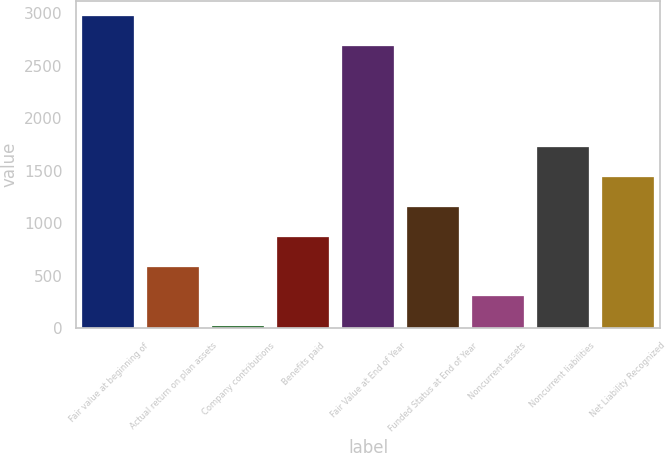Convert chart. <chart><loc_0><loc_0><loc_500><loc_500><bar_chart><fcel>Fair value at beginning of<fcel>Actual return on plan assets<fcel>Company contributions<fcel>Benefits paid<fcel>Fair Value at End of Year<fcel>Funded Status at End of Year<fcel>Noncurrent assets<fcel>Noncurrent liabilities<fcel>Net Liability Recognized<nl><fcel>2970.36<fcel>585.52<fcel>14.6<fcel>870.98<fcel>2684.9<fcel>1156.44<fcel>300.06<fcel>1727.36<fcel>1441.9<nl></chart> 